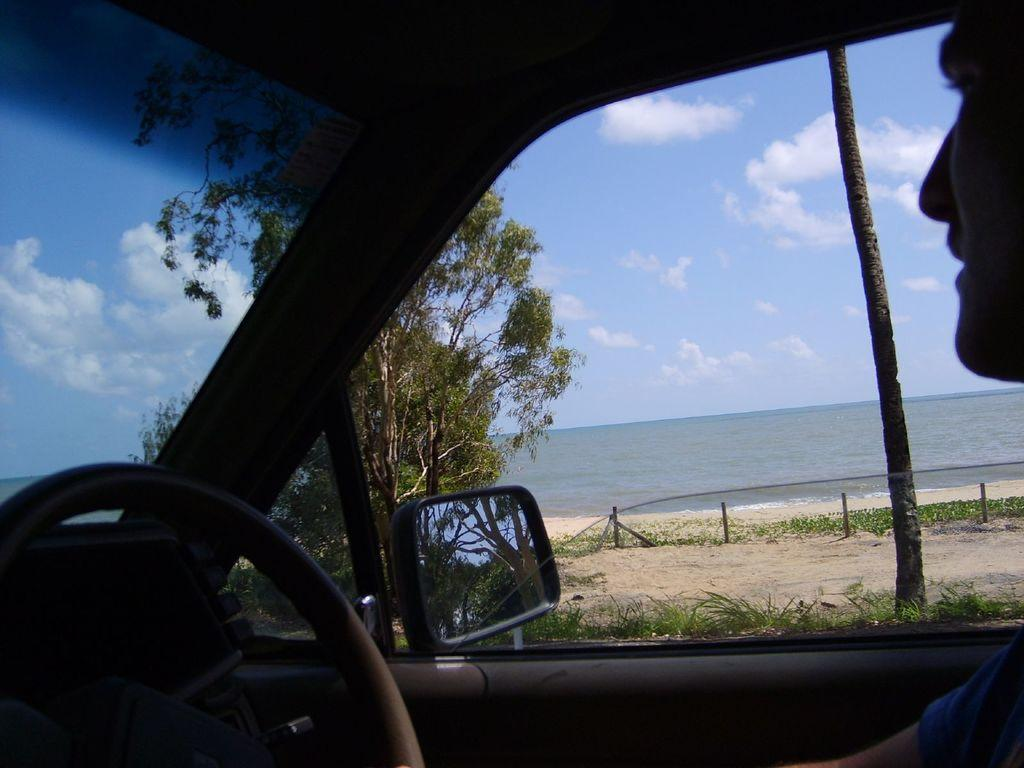Where is the image taken from? The image is captured inside a car. Who is present in the car? There is a man sitting in front of the steering wheel. What can be seen outside the car? Trees, plants, and a sea are visible outside the car. How many houses can be seen in the image? There are no houses visible in the image; it only shows a man inside a car with trees, plants, and a sea outside. What type of plough is being used to cultivate the sea in the image? There is no plough present in the image, and the sea is not being cultivated. 